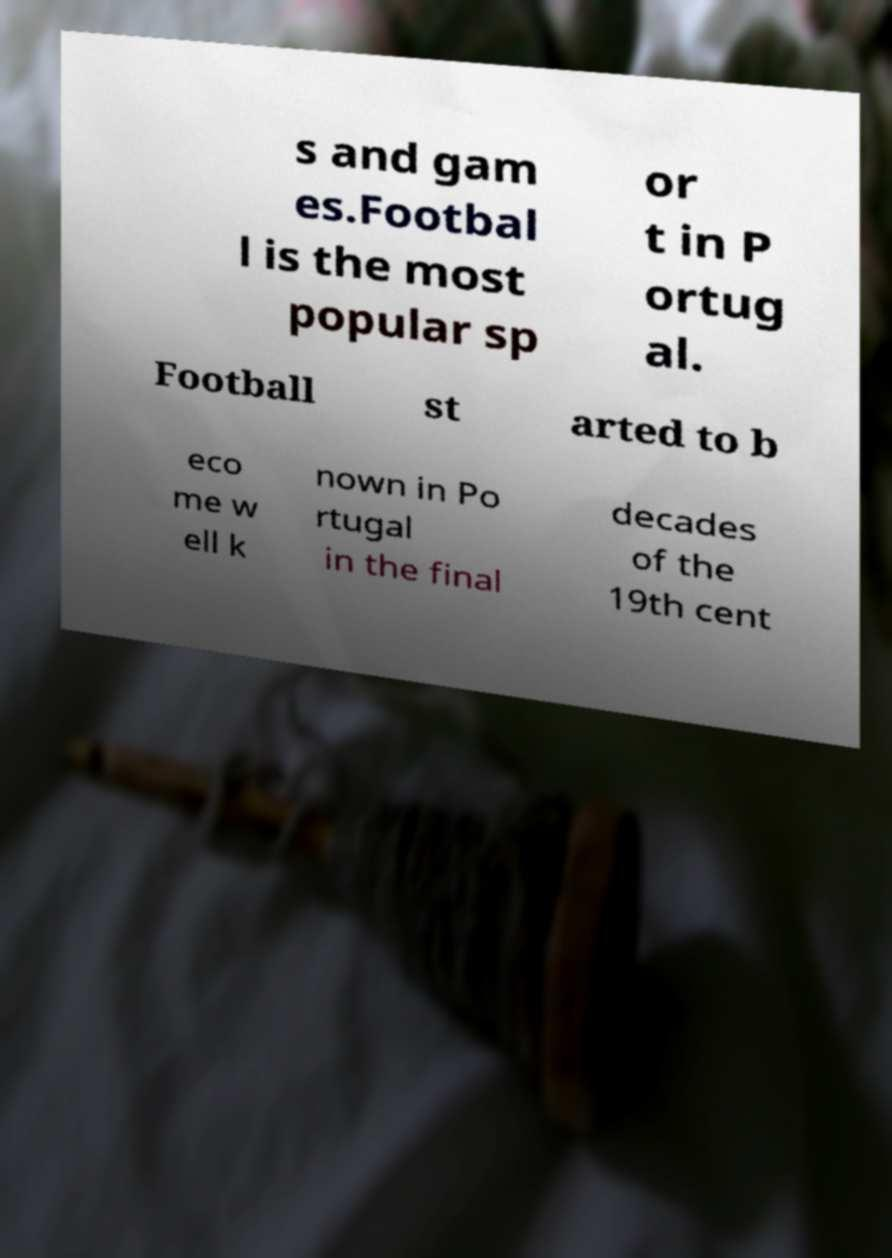Can you read and provide the text displayed in the image?This photo seems to have some interesting text. Can you extract and type it out for me? s and gam es.Footbal l is the most popular sp or t in P ortug al. Football st arted to b eco me w ell k nown in Po rtugal in the final decades of the 19th cent 